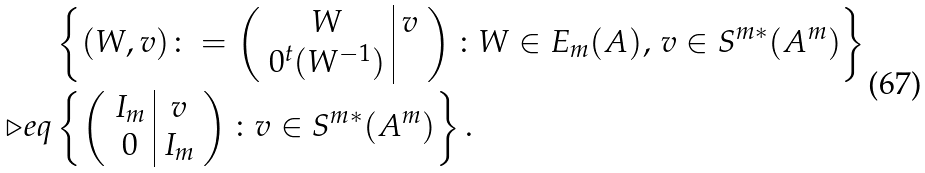Convert formula to latex. <formula><loc_0><loc_0><loc_500><loc_500>& \left \{ ( W , v ) \colon = \left ( \begin{array} { c | c } W & v \\ 0 ^ { t } ( W ^ { - 1 } ) \end{array} \right ) \colon W \in E _ { m } ( A ) , \, v \in S ^ { m * } ( A ^ { m } ) \right \} \\ \triangleright e q & \left \{ \left ( \begin{array} { c | c } I _ { m } & v \\ 0 & I _ { m } \end{array} \right ) \colon v \in S ^ { m * } ( A ^ { m } ) \right \} .</formula> 